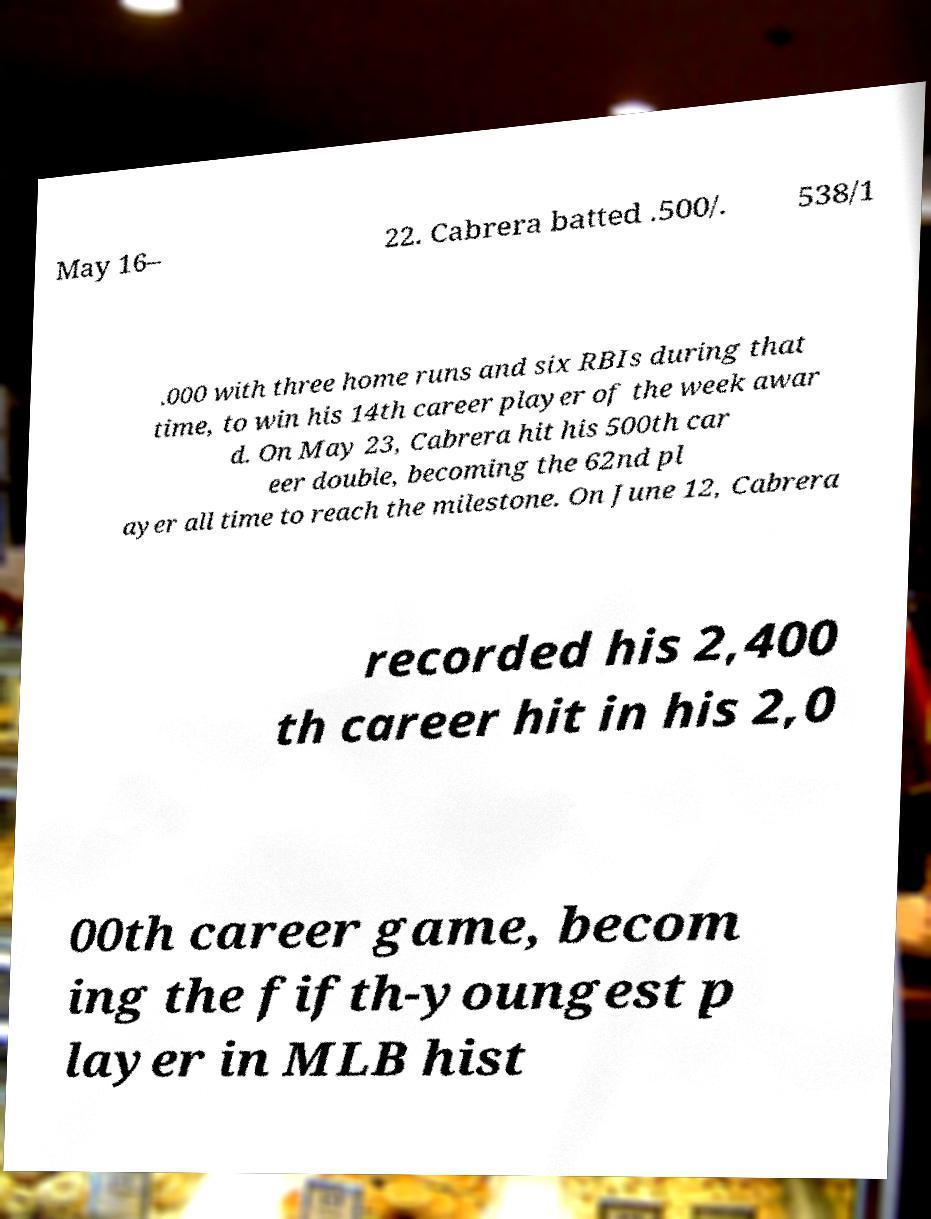Could you extract and type out the text from this image? May 16– 22. Cabrera batted .500/. 538/1 .000 with three home runs and six RBIs during that time, to win his 14th career player of the week awar d. On May 23, Cabrera hit his 500th car eer double, becoming the 62nd pl ayer all time to reach the milestone. On June 12, Cabrera recorded his 2,400 th career hit in his 2,0 00th career game, becom ing the fifth-youngest p layer in MLB hist 